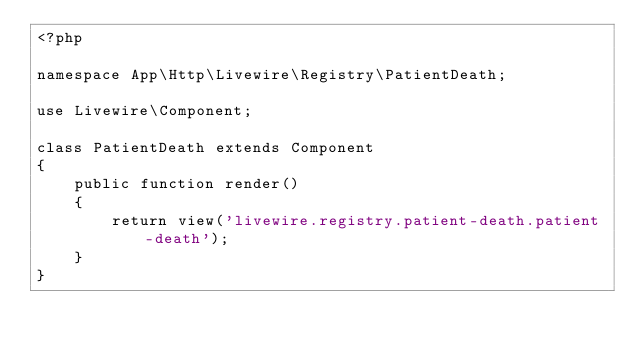<code> <loc_0><loc_0><loc_500><loc_500><_PHP_><?php

namespace App\Http\Livewire\Registry\PatientDeath;

use Livewire\Component;

class PatientDeath extends Component
{
    public function render()
    {
        return view('livewire.registry.patient-death.patient-death');
    }
}
</code> 